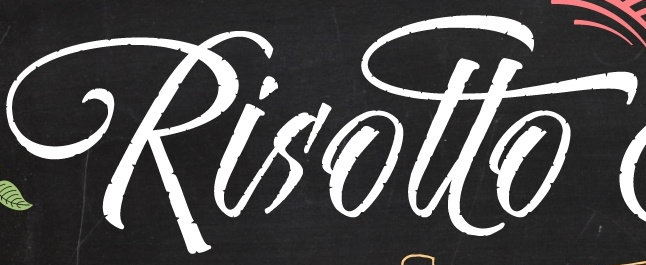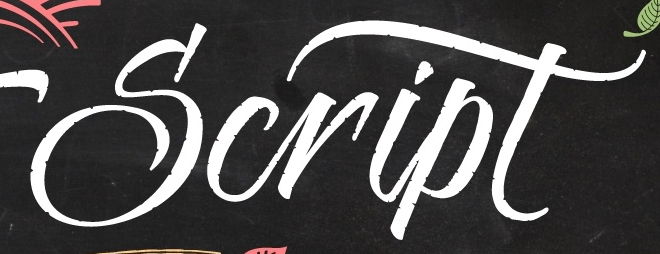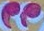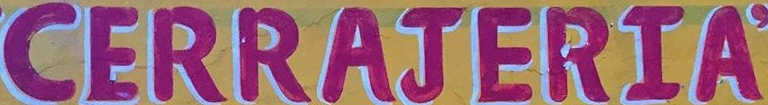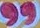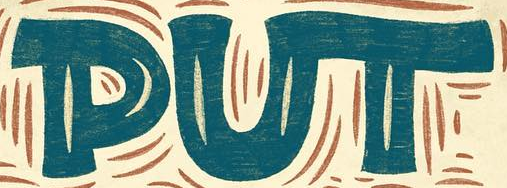Read the text content from these images in order, separated by a semicolon. Risotto; Script; "; CERRAJERIA; "; PUT 